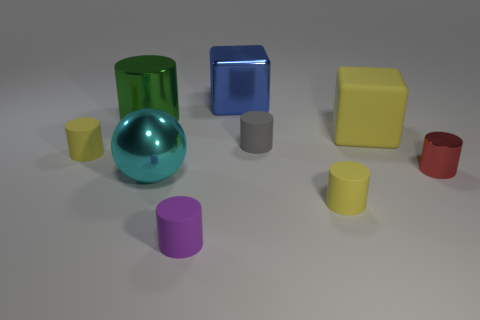Subtract all red cylinders. How many cylinders are left? 5 Subtract all tiny shiny cylinders. How many cylinders are left? 5 Add 1 big shiny things. How many objects exist? 10 Subtract all brown cylinders. Subtract all red blocks. How many cylinders are left? 6 Subtract all spheres. How many objects are left? 8 Subtract 0 green spheres. How many objects are left? 9 Subtract all small cyan rubber cylinders. Subtract all cyan metallic spheres. How many objects are left? 8 Add 2 tiny red metal objects. How many tiny red metal objects are left? 3 Add 6 cyan matte cylinders. How many cyan matte cylinders exist? 6 